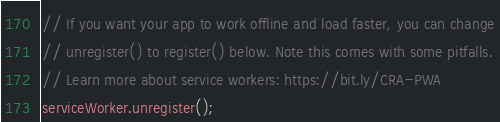<code> <loc_0><loc_0><loc_500><loc_500><_JavaScript_>
// If you want your app to work offline and load faster, you can change
// unregister() to register() below. Note this comes with some pitfalls.
// Learn more about service workers: https://bit.ly/CRA-PWA
serviceWorker.unregister();
</code> 